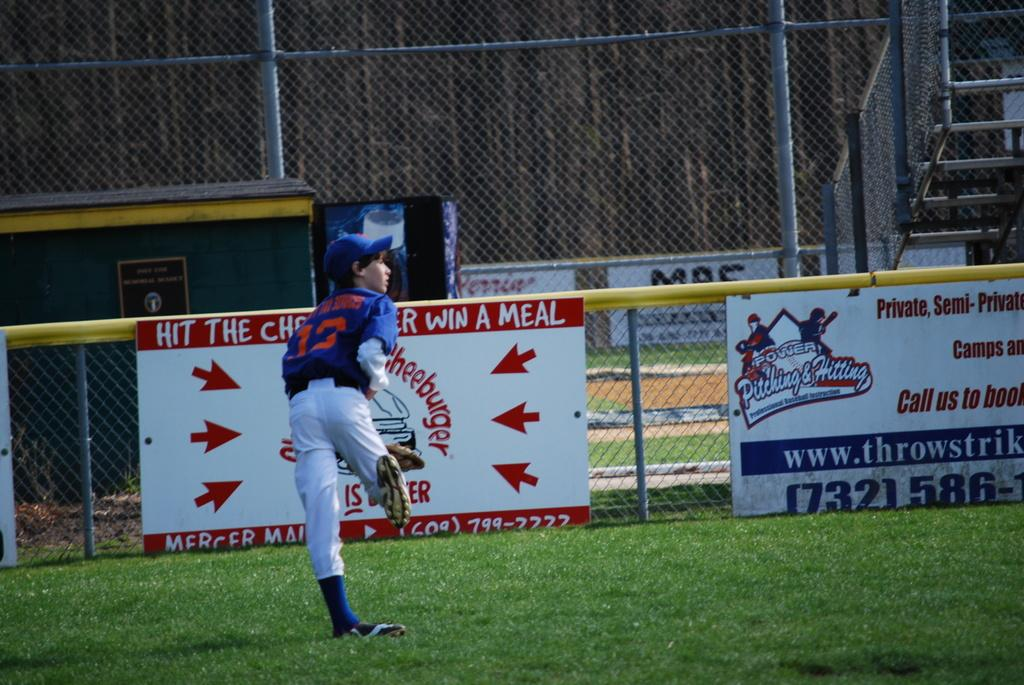<image>
Relay a brief, clear account of the picture shown. Player number 13 who plays in the outfield tries to catch a baseball. 